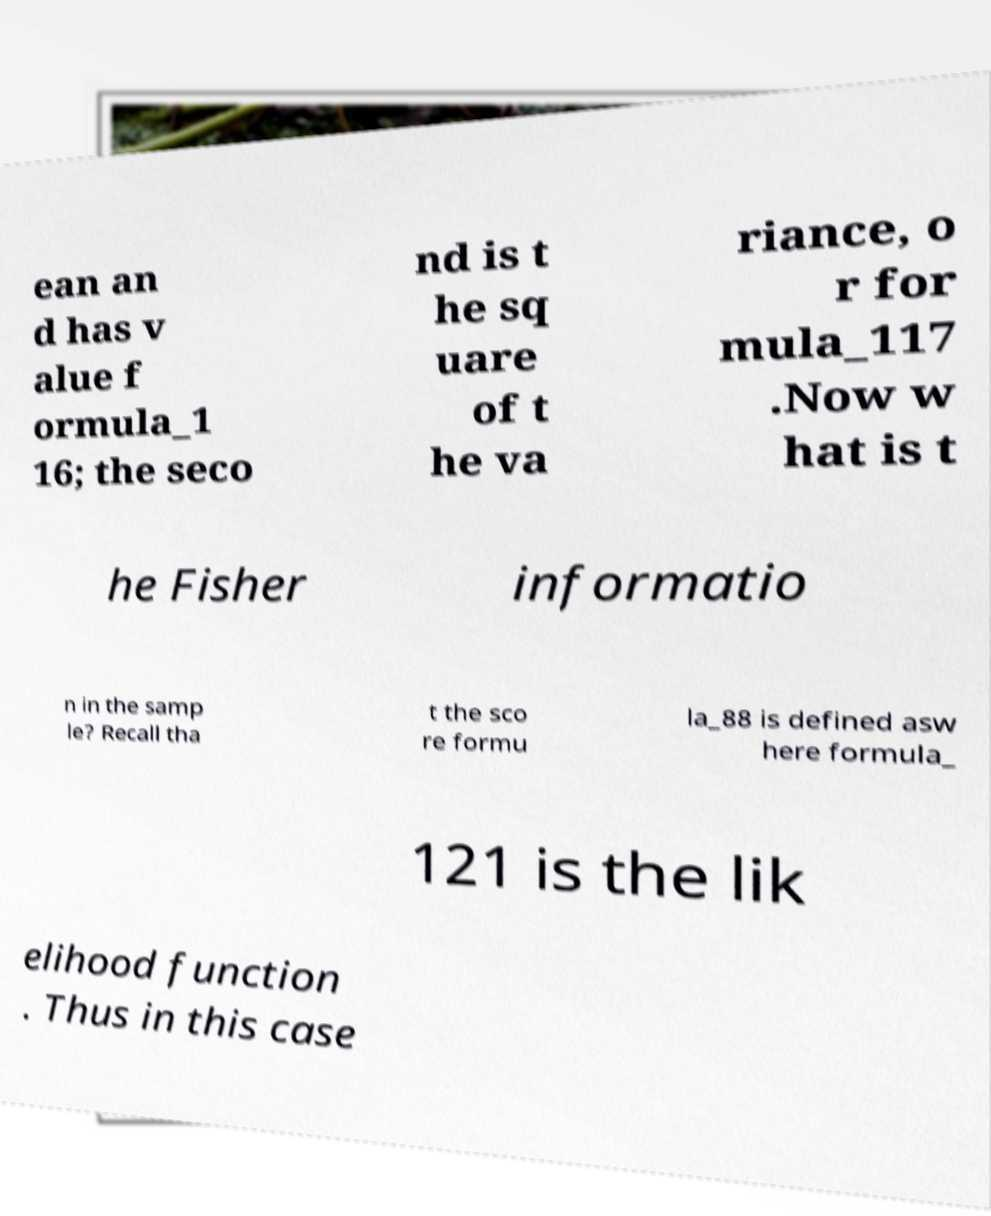Can you accurately transcribe the text from the provided image for me? ean an d has v alue f ormula_1 16; the seco nd is t he sq uare of t he va riance, o r for mula_117 .Now w hat is t he Fisher informatio n in the samp le? Recall tha t the sco re formu la_88 is defined asw here formula_ 121 is the lik elihood function . Thus in this case 